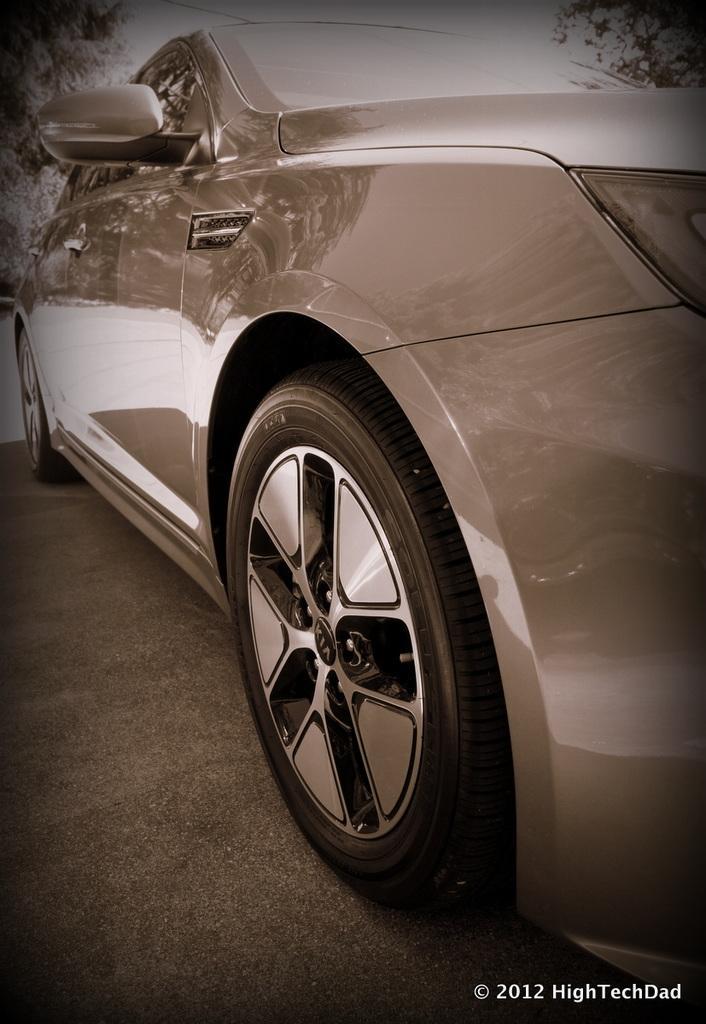How would you summarize this image in a sentence or two? In this picture there is a car on the road and there are trees on either sides of it and there is something written in the right bottom corner. 